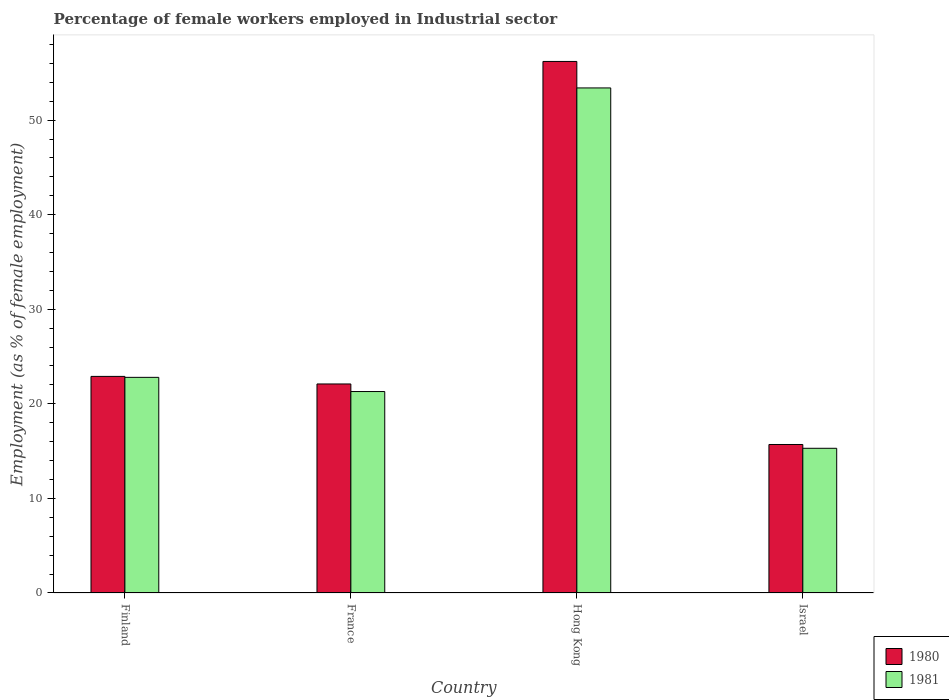How many different coloured bars are there?
Your answer should be very brief. 2. Are the number of bars per tick equal to the number of legend labels?
Your answer should be very brief. Yes. Are the number of bars on each tick of the X-axis equal?
Keep it short and to the point. Yes. How many bars are there on the 4th tick from the left?
Ensure brevity in your answer.  2. How many bars are there on the 4th tick from the right?
Provide a short and direct response. 2. What is the label of the 4th group of bars from the left?
Your response must be concise. Israel. In how many cases, is the number of bars for a given country not equal to the number of legend labels?
Offer a terse response. 0. What is the percentage of females employed in Industrial sector in 1980 in Israel?
Your response must be concise. 15.7. Across all countries, what is the maximum percentage of females employed in Industrial sector in 1981?
Your answer should be compact. 53.4. Across all countries, what is the minimum percentage of females employed in Industrial sector in 1980?
Give a very brief answer. 15.7. In which country was the percentage of females employed in Industrial sector in 1980 maximum?
Provide a short and direct response. Hong Kong. In which country was the percentage of females employed in Industrial sector in 1980 minimum?
Your response must be concise. Israel. What is the total percentage of females employed in Industrial sector in 1981 in the graph?
Keep it short and to the point. 112.8. What is the difference between the percentage of females employed in Industrial sector in 1981 in Finland and that in France?
Give a very brief answer. 1.5. What is the difference between the percentage of females employed in Industrial sector in 1980 in Hong Kong and the percentage of females employed in Industrial sector in 1981 in Israel?
Your answer should be compact. 40.9. What is the average percentage of females employed in Industrial sector in 1980 per country?
Give a very brief answer. 29.23. What is the difference between the percentage of females employed in Industrial sector of/in 1980 and percentage of females employed in Industrial sector of/in 1981 in Finland?
Make the answer very short. 0.1. What is the ratio of the percentage of females employed in Industrial sector in 1980 in Finland to that in Israel?
Provide a short and direct response. 1.46. Is the percentage of females employed in Industrial sector in 1981 in Hong Kong less than that in Israel?
Give a very brief answer. No. Is the difference between the percentage of females employed in Industrial sector in 1980 in Finland and France greater than the difference between the percentage of females employed in Industrial sector in 1981 in Finland and France?
Provide a short and direct response. No. What is the difference between the highest and the second highest percentage of females employed in Industrial sector in 1980?
Give a very brief answer. 33.3. What is the difference between the highest and the lowest percentage of females employed in Industrial sector in 1981?
Keep it short and to the point. 38.1. In how many countries, is the percentage of females employed in Industrial sector in 1981 greater than the average percentage of females employed in Industrial sector in 1981 taken over all countries?
Offer a terse response. 1. Is the sum of the percentage of females employed in Industrial sector in 1981 in France and Israel greater than the maximum percentage of females employed in Industrial sector in 1980 across all countries?
Make the answer very short. No. What does the 1st bar from the left in Hong Kong represents?
Offer a very short reply. 1980. How many countries are there in the graph?
Offer a very short reply. 4. Are the values on the major ticks of Y-axis written in scientific E-notation?
Make the answer very short. No. Does the graph contain grids?
Make the answer very short. No. Where does the legend appear in the graph?
Make the answer very short. Bottom right. What is the title of the graph?
Provide a succinct answer. Percentage of female workers employed in Industrial sector. What is the label or title of the X-axis?
Provide a short and direct response. Country. What is the label or title of the Y-axis?
Make the answer very short. Employment (as % of female employment). What is the Employment (as % of female employment) of 1980 in Finland?
Give a very brief answer. 22.9. What is the Employment (as % of female employment) of 1981 in Finland?
Give a very brief answer. 22.8. What is the Employment (as % of female employment) in 1980 in France?
Offer a terse response. 22.1. What is the Employment (as % of female employment) of 1981 in France?
Give a very brief answer. 21.3. What is the Employment (as % of female employment) of 1980 in Hong Kong?
Your answer should be compact. 56.2. What is the Employment (as % of female employment) in 1981 in Hong Kong?
Ensure brevity in your answer.  53.4. What is the Employment (as % of female employment) of 1980 in Israel?
Offer a very short reply. 15.7. What is the Employment (as % of female employment) of 1981 in Israel?
Offer a terse response. 15.3. Across all countries, what is the maximum Employment (as % of female employment) of 1980?
Offer a terse response. 56.2. Across all countries, what is the maximum Employment (as % of female employment) in 1981?
Keep it short and to the point. 53.4. Across all countries, what is the minimum Employment (as % of female employment) of 1980?
Keep it short and to the point. 15.7. Across all countries, what is the minimum Employment (as % of female employment) in 1981?
Your response must be concise. 15.3. What is the total Employment (as % of female employment) in 1980 in the graph?
Your response must be concise. 116.9. What is the total Employment (as % of female employment) of 1981 in the graph?
Keep it short and to the point. 112.8. What is the difference between the Employment (as % of female employment) of 1980 in Finland and that in France?
Make the answer very short. 0.8. What is the difference between the Employment (as % of female employment) of 1980 in Finland and that in Hong Kong?
Provide a succinct answer. -33.3. What is the difference between the Employment (as % of female employment) in 1981 in Finland and that in Hong Kong?
Your answer should be very brief. -30.6. What is the difference between the Employment (as % of female employment) in 1980 in Finland and that in Israel?
Offer a very short reply. 7.2. What is the difference between the Employment (as % of female employment) of 1980 in France and that in Hong Kong?
Your response must be concise. -34.1. What is the difference between the Employment (as % of female employment) of 1981 in France and that in Hong Kong?
Provide a succinct answer. -32.1. What is the difference between the Employment (as % of female employment) of 1980 in Hong Kong and that in Israel?
Provide a succinct answer. 40.5. What is the difference between the Employment (as % of female employment) of 1981 in Hong Kong and that in Israel?
Ensure brevity in your answer.  38.1. What is the difference between the Employment (as % of female employment) in 1980 in Finland and the Employment (as % of female employment) in 1981 in Hong Kong?
Offer a terse response. -30.5. What is the difference between the Employment (as % of female employment) in 1980 in Finland and the Employment (as % of female employment) in 1981 in Israel?
Your response must be concise. 7.6. What is the difference between the Employment (as % of female employment) in 1980 in France and the Employment (as % of female employment) in 1981 in Hong Kong?
Ensure brevity in your answer.  -31.3. What is the difference between the Employment (as % of female employment) of 1980 in France and the Employment (as % of female employment) of 1981 in Israel?
Your answer should be very brief. 6.8. What is the difference between the Employment (as % of female employment) of 1980 in Hong Kong and the Employment (as % of female employment) of 1981 in Israel?
Ensure brevity in your answer.  40.9. What is the average Employment (as % of female employment) in 1980 per country?
Provide a succinct answer. 29.23. What is the average Employment (as % of female employment) in 1981 per country?
Ensure brevity in your answer.  28.2. What is the difference between the Employment (as % of female employment) of 1980 and Employment (as % of female employment) of 1981 in Finland?
Provide a succinct answer. 0.1. What is the difference between the Employment (as % of female employment) of 1980 and Employment (as % of female employment) of 1981 in Hong Kong?
Your answer should be very brief. 2.8. What is the difference between the Employment (as % of female employment) in 1980 and Employment (as % of female employment) in 1981 in Israel?
Keep it short and to the point. 0.4. What is the ratio of the Employment (as % of female employment) of 1980 in Finland to that in France?
Offer a terse response. 1.04. What is the ratio of the Employment (as % of female employment) in 1981 in Finland to that in France?
Make the answer very short. 1.07. What is the ratio of the Employment (as % of female employment) of 1980 in Finland to that in Hong Kong?
Provide a succinct answer. 0.41. What is the ratio of the Employment (as % of female employment) of 1981 in Finland to that in Hong Kong?
Make the answer very short. 0.43. What is the ratio of the Employment (as % of female employment) in 1980 in Finland to that in Israel?
Provide a succinct answer. 1.46. What is the ratio of the Employment (as % of female employment) in 1981 in Finland to that in Israel?
Your answer should be very brief. 1.49. What is the ratio of the Employment (as % of female employment) of 1980 in France to that in Hong Kong?
Your answer should be very brief. 0.39. What is the ratio of the Employment (as % of female employment) of 1981 in France to that in Hong Kong?
Ensure brevity in your answer.  0.4. What is the ratio of the Employment (as % of female employment) of 1980 in France to that in Israel?
Ensure brevity in your answer.  1.41. What is the ratio of the Employment (as % of female employment) of 1981 in France to that in Israel?
Make the answer very short. 1.39. What is the ratio of the Employment (as % of female employment) of 1980 in Hong Kong to that in Israel?
Offer a terse response. 3.58. What is the ratio of the Employment (as % of female employment) in 1981 in Hong Kong to that in Israel?
Ensure brevity in your answer.  3.49. What is the difference between the highest and the second highest Employment (as % of female employment) of 1980?
Offer a very short reply. 33.3. What is the difference between the highest and the second highest Employment (as % of female employment) in 1981?
Your answer should be compact. 30.6. What is the difference between the highest and the lowest Employment (as % of female employment) in 1980?
Your answer should be compact. 40.5. What is the difference between the highest and the lowest Employment (as % of female employment) of 1981?
Give a very brief answer. 38.1. 